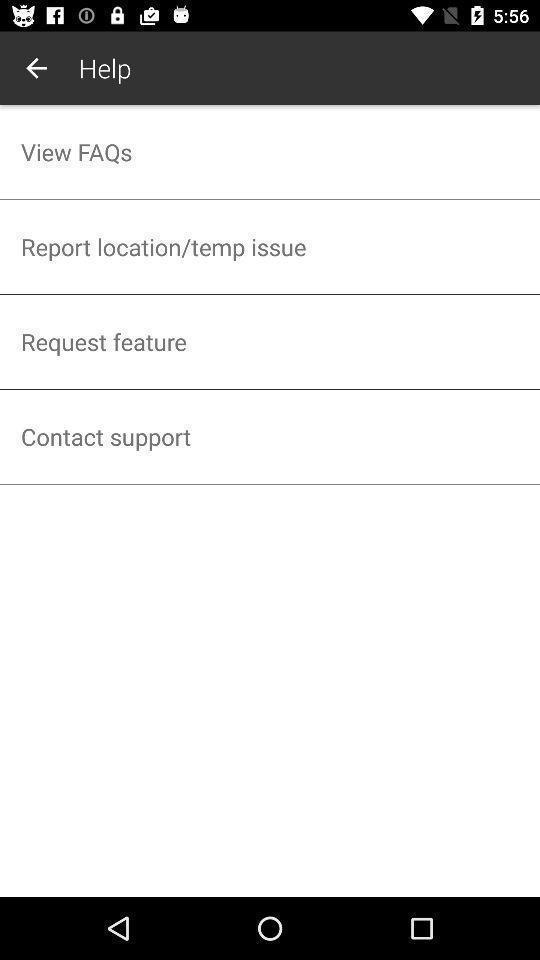Summarize the main components in this picture. Screen shows a help desk section on a device. 